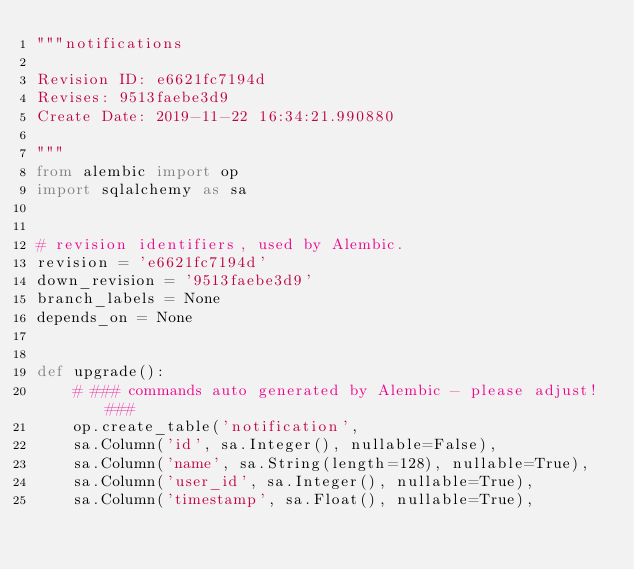Convert code to text. <code><loc_0><loc_0><loc_500><loc_500><_Python_>"""notifications

Revision ID: e6621fc7194d
Revises: 9513faebe3d9
Create Date: 2019-11-22 16:34:21.990880

"""
from alembic import op
import sqlalchemy as sa


# revision identifiers, used by Alembic.
revision = 'e6621fc7194d'
down_revision = '9513faebe3d9'
branch_labels = None
depends_on = None


def upgrade():
    # ### commands auto generated by Alembic - please adjust! ###
    op.create_table('notification',
    sa.Column('id', sa.Integer(), nullable=False),
    sa.Column('name', sa.String(length=128), nullable=True),
    sa.Column('user_id', sa.Integer(), nullable=True),
    sa.Column('timestamp', sa.Float(), nullable=True),</code> 